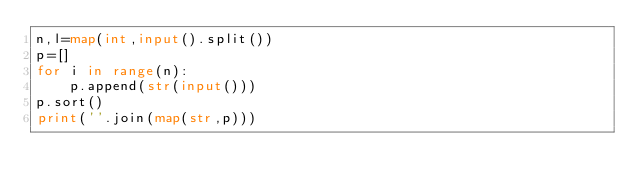<code> <loc_0><loc_0><loc_500><loc_500><_Python_>n,l=map(int,input().split())
p=[]
for i in range(n):
    p.append(str(input()))
p.sort()
print(''.join(map(str,p)))</code> 